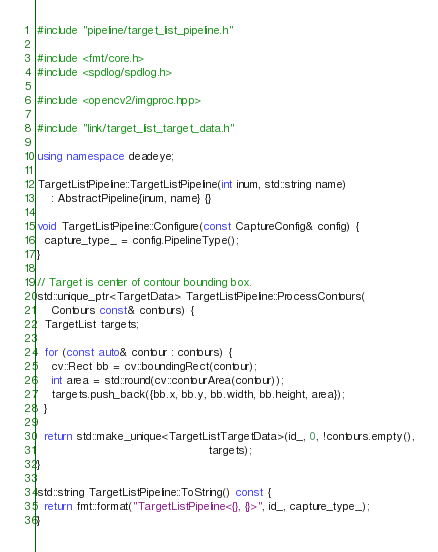<code> <loc_0><loc_0><loc_500><loc_500><_C++_>#include "pipeline/target_list_pipeline.h"

#include <fmt/core.h>
#include <spdlog/spdlog.h>

#include <opencv2/imgproc.hpp>

#include "link/target_list_target_data.h"

using namespace deadeye;

TargetListPipeline::TargetListPipeline(int inum, std::string name)
    : AbstractPipeline{inum, name} {}

void TargetListPipeline::Configure(const CaptureConfig& config) {
  capture_type_ = config.PipelineType();
}

// Target is center of contour bounding box.
std::unique_ptr<TargetData> TargetListPipeline::ProcessContours(
    Contours const& contours) {
  TargetList targets;

  for (const auto& contour : contours) {
    cv::Rect bb = cv::boundingRect(contour);
    int area = std::round(cv::contourArea(contour));
    targets.push_back({bb.x, bb.y, bb.width, bb.height, area});
  }

  return std::make_unique<TargetListTargetData>(id_, 0, !contours.empty(),
                                                targets);
}

std::string TargetListPipeline::ToString() const {
  return fmt::format("TargetListPipeline<{}, {}>", id_, capture_type_);
}
</code> 